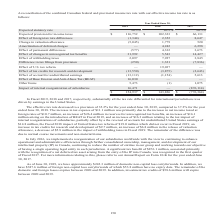According to Opentext Corporation's financial document, What does the table represent? reconciliation of the combined Canadian federal and provincial income tax rate with our effective income tax rate. The document states: "A reconciliation of the combined Canadian federal and provincial income tax rate with our effective income tax rate is as follows:..." Also, How much domestic non-capital loss carryforwards are there as of June 30, 2019? approximately $242.3 million. The document states: "As of June 30, 2019, we have approximately $242.3 million of domestic non-capital loss carryforwards. In addition, we have $387.6 million of foreign n..." Also, What fiscal years are included in the table? The document contains multiple relevant values: 2019, 2018, 2017. From the document: "2019 2018 2017 Expected statutory rate 26.5% 26.5% 26.5% Expected provision for income taxes $ 116,752 $ 102,323 $ 2019 2018 2017 Expected statutory r..." Also, can you calculate: What is the difference in Expected provision for income taxes from fiscal year 2018 to 2019? Based on the calculation: 116,752-102,323, the result is 14429 (in thousands). This is based on the information: "% Expected provision for income taxes $ 116,752 $ 102,323 $ 66,131 Effect of foreign tax rate differences (1,344) 2,352 8,647 Change in valuation allowance ( 26.5% 26.5% Expected provision for income ..." The key data points involved are: 102,323, 116,752. Also, can you calculate: What is the average annual Effect of foreign tax rate differences?  To answer this question, I need to perform calculations using the financial data. The calculation is: (-1,344+2,352+8,647)/3, which equals 3218.33 (in thousands). This is based on the information: "31 Effect of foreign tax rate differences (1,344) 2,352 8,647 Change in valuation allowance (5,045) 1,779 520 Amortization of deferred charges — 4,242 6,29 $ 66,131 Effect of foreign tax rate differen..." The key data points involved are: 1,344, 2,352, 8,647. Also, can you calculate: What is the difference in the Effect of changes in unrecognized tax benefits from fiscal year 2017 to 2019? Based on the calculation: 31,992-14,427, the result is 17565 (in thousands). This is based on the information: "73 Effect of changes in unrecognized tax benefits 31,992 5,543 14,427 Effect of withholding taxes 2,097 7,927 3,845 Difference in tax filings from provision changes in unrecognized tax benefits 31,992..." The key data points involved are: 14,427, 31,992. 